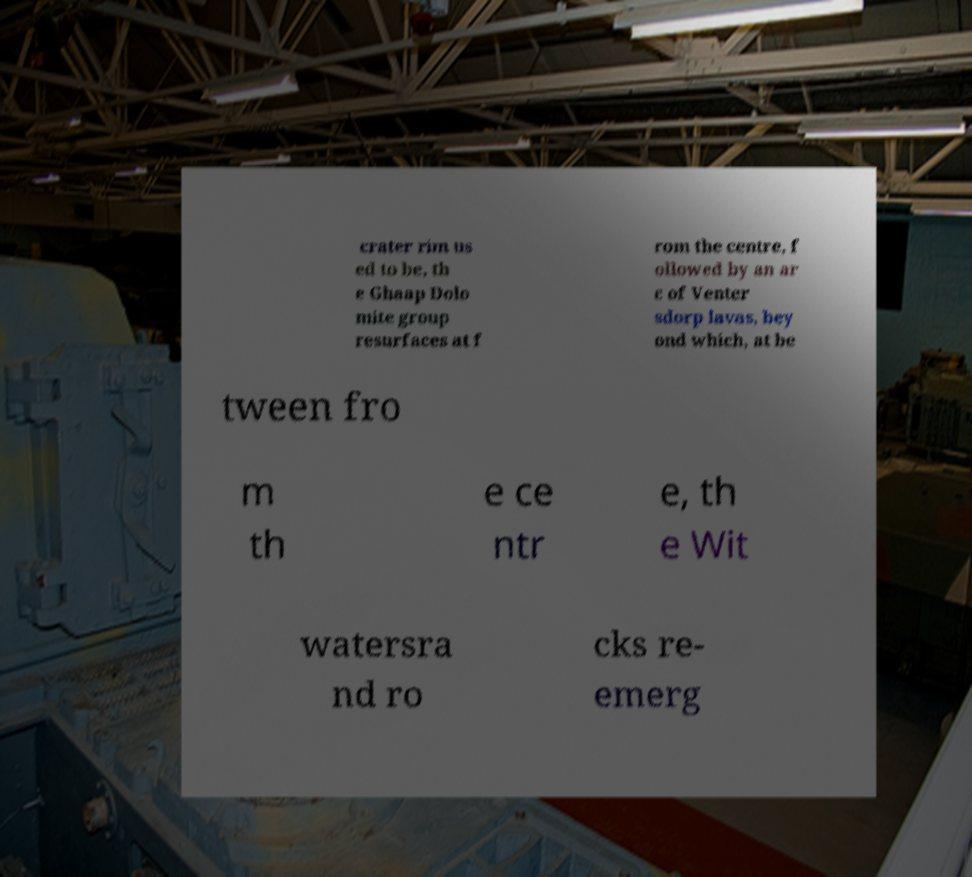Please identify and transcribe the text found in this image. crater rim us ed to be, th e Ghaap Dolo mite group resurfaces at f rom the centre, f ollowed by an ar c of Venter sdorp lavas, bey ond which, at be tween fro m th e ce ntr e, th e Wit watersra nd ro cks re- emerg 